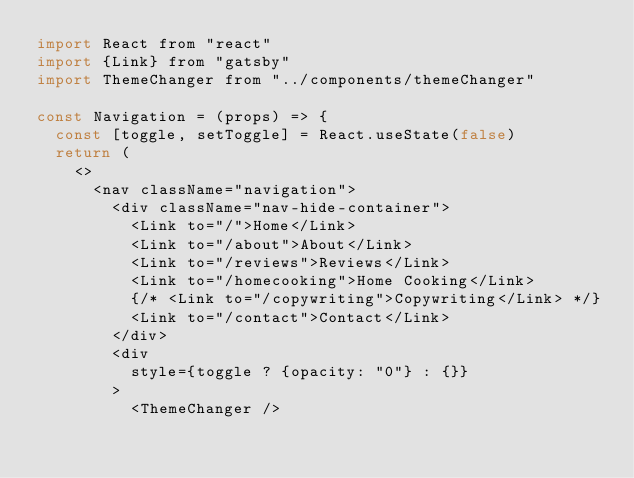Convert code to text. <code><loc_0><loc_0><loc_500><loc_500><_JavaScript_>import React from "react"
import {Link} from "gatsby"
import ThemeChanger from "../components/themeChanger"

const Navigation = (props) => {
  const [toggle, setToggle] = React.useState(false)
  return (
    <>
      <nav className="navigation"> 
        <div className="nav-hide-container">
          <Link to="/">Home</Link>
          <Link to="/about">About</Link>
          <Link to="/reviews">Reviews</Link>
          <Link to="/homecooking">Home Cooking</Link>
          {/* <Link to="/copywriting">Copywriting</Link> */}
          <Link to="/contact">Contact</Link>
        </div>
        <div
          style={toggle ? {opacity: "0"} : {}}
        >
          <ThemeChanger /></code> 